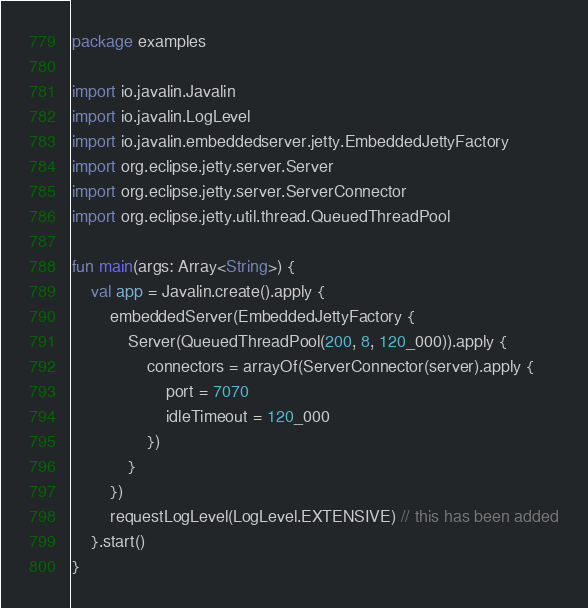<code> <loc_0><loc_0><loc_500><loc_500><_Kotlin_>package examples

import io.javalin.Javalin
import io.javalin.LogLevel
import io.javalin.embeddedserver.jetty.EmbeddedJettyFactory
import org.eclipse.jetty.server.Server
import org.eclipse.jetty.server.ServerConnector
import org.eclipse.jetty.util.thread.QueuedThreadPool

fun main(args: Array<String>) {
    val app = Javalin.create().apply {
        embeddedServer(EmbeddedJettyFactory {
            Server(QueuedThreadPool(200, 8, 120_000)).apply {
                connectors = arrayOf(ServerConnector(server).apply {
                    port = 7070
                    idleTimeout = 120_000
                })
            }
        })
        requestLogLevel(LogLevel.EXTENSIVE) // this has been added
    }.start()
}
</code> 